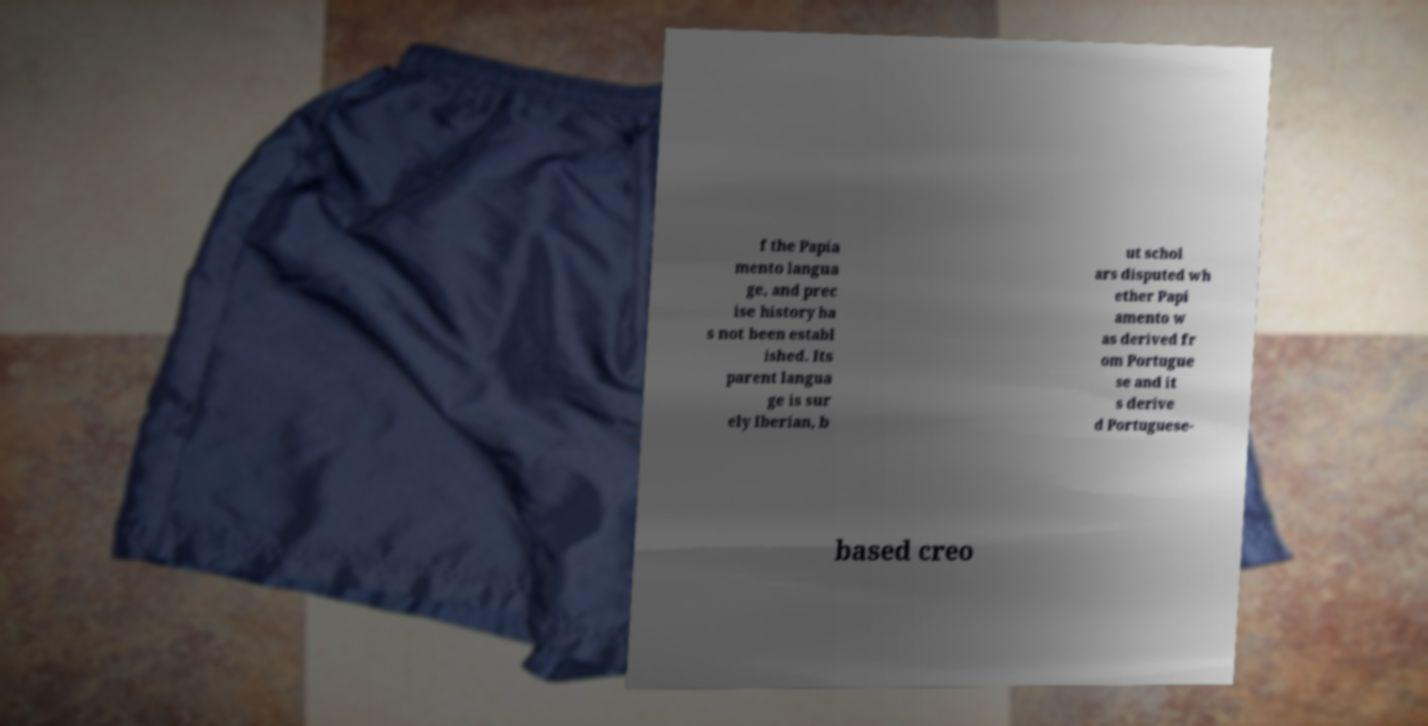There's text embedded in this image that I need extracted. Can you transcribe it verbatim? f the Papia mento langua ge, and prec ise history ha s not been establ ished. Its parent langua ge is sur ely Iberian, b ut schol ars disputed wh ether Papi amento w as derived fr om Portugue se and it s derive d Portuguese- based creo 